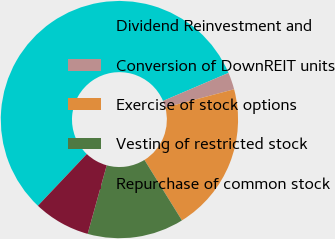Convert chart. <chart><loc_0><loc_0><loc_500><loc_500><pie_chart><fcel>Dividend Reinvestment and<fcel>Conversion of DownREIT units<fcel>Exercise of stock options<fcel>Vesting of restricted stock<fcel>Repurchase of common stock<nl><fcel>56.51%<fcel>2.32%<fcel>20.28%<fcel>13.15%<fcel>7.74%<nl></chart> 